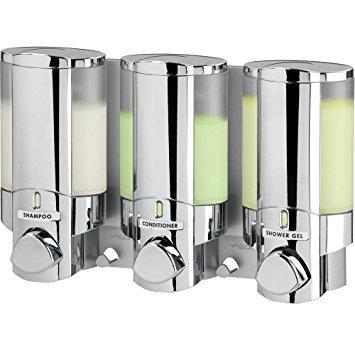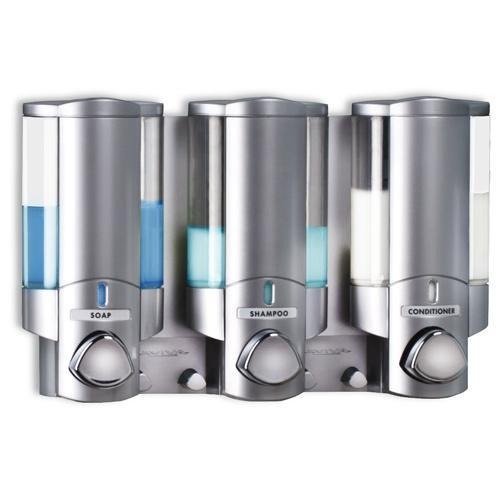The first image is the image on the left, the second image is the image on the right. Examine the images to the left and right. Is the description "There are three dispensers in which the top half is fully silver with only one line of an open window to see liquid." accurate? Answer yes or no. No. The first image is the image on the left, the second image is the image on the right. Analyze the images presented: Is the assertion "At least one image contains three dispensers which are all not transparent." valid? Answer yes or no. No. 